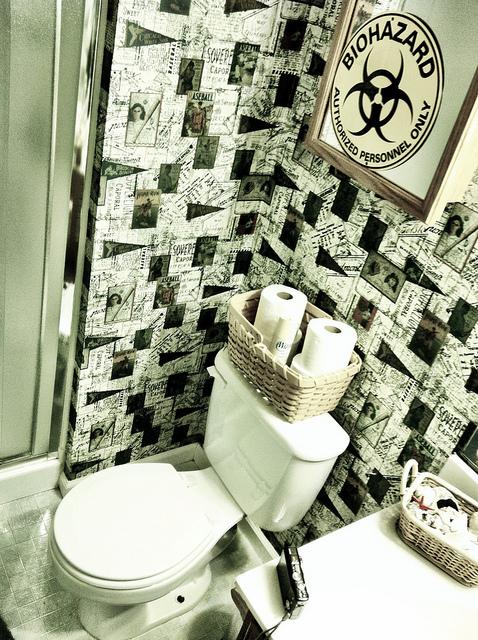Why is there a biohazard sign above the toilet?
Short answer required. Decoration. Is there extra toilet paper?
Write a very short answer. Yes. What type of room is in the picture?
Keep it brief. Bathroom. 